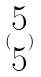<formula> <loc_0><loc_0><loc_500><loc_500>( \begin{matrix} 5 \\ 5 \end{matrix} )</formula> 